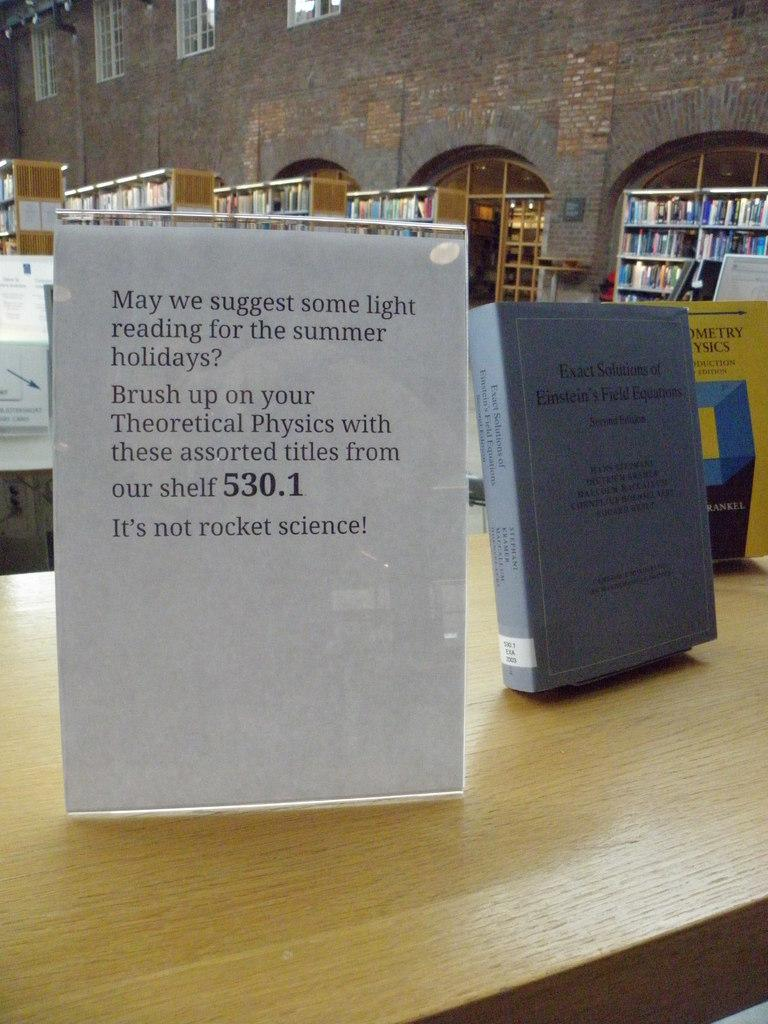<image>
Offer a succinct explanation of the picture presented. A display sign suggests reading up on the subject of Theoretical Physics. 